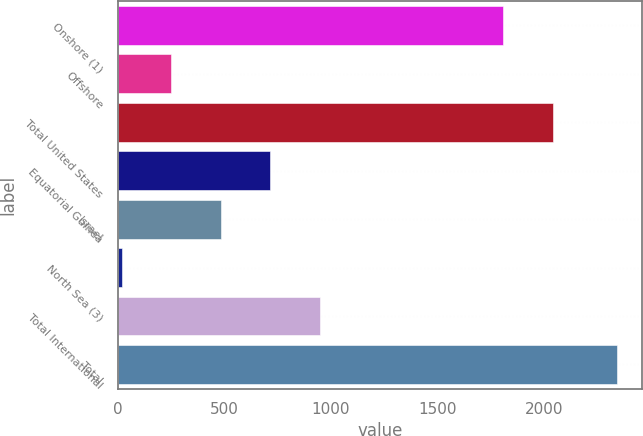Convert chart. <chart><loc_0><loc_0><loc_500><loc_500><bar_chart><fcel>Onshore (1)<fcel>Offshore<fcel>Total United States<fcel>Equatorial Guinea<fcel>Israel<fcel>North Sea (3)<fcel>Total International<fcel>Total<nl><fcel>1808<fcel>252<fcel>2040<fcel>716<fcel>484<fcel>20<fcel>948<fcel>2340<nl></chart> 